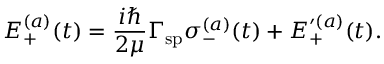Convert formula to latex. <formula><loc_0><loc_0><loc_500><loc_500>E _ { + } ^ { ( a ) } ( t ) = \frac { i } { 2 \mu } \Gamma _ { s p } \sigma _ { - } ^ { ( a ) } ( t ) + E _ { + } ^ { \prime ( a ) } ( t ) .</formula> 